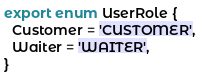Convert code to text. <code><loc_0><loc_0><loc_500><loc_500><_TypeScript_>export enum UserRole {
  Customer = 'CUSTOMER',
  Waiter = 'WAITER',
}
</code> 